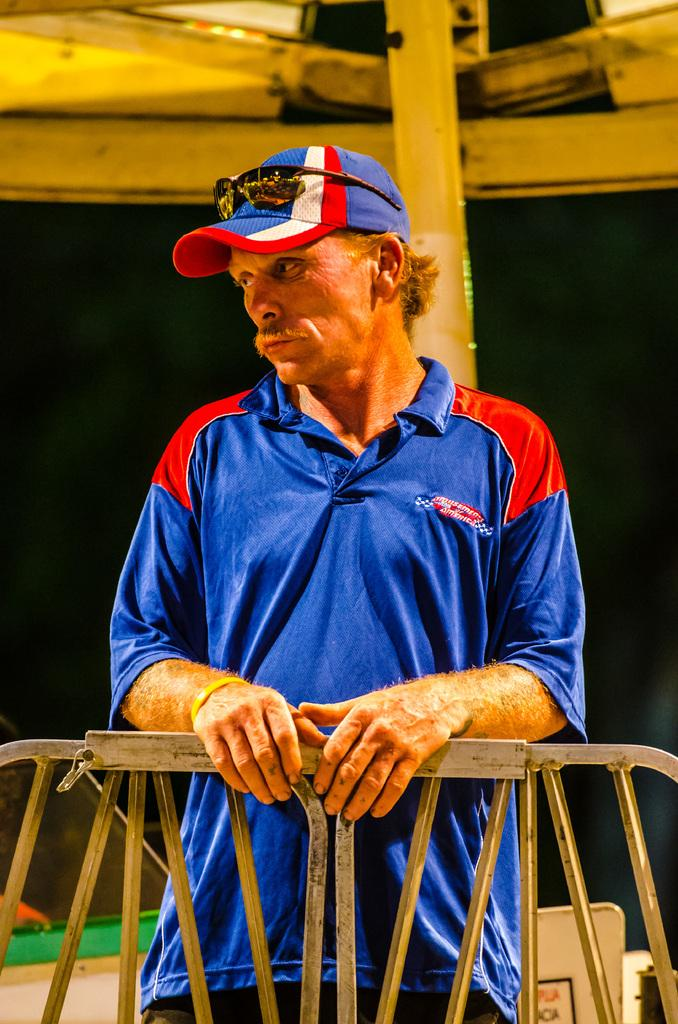Who is the main subject in the image? There is a man in the middle of the image. What is the man wearing on his upper body? The man is wearing a t-shirt. What type of headwear is the man wearing? The man is wearing a cap. What architectural feature can be seen in the image? There is an iron grill visible in the image. What type of drum can be heard during the rainstorm in the image? There is no drum or rainstorm present in the image; it features a man wearing a t-shirt and cap, with an iron grill visible. What key is used to unlock the door in the image? A: There is no door or key present in the image; it only features a man and an iron grill. 